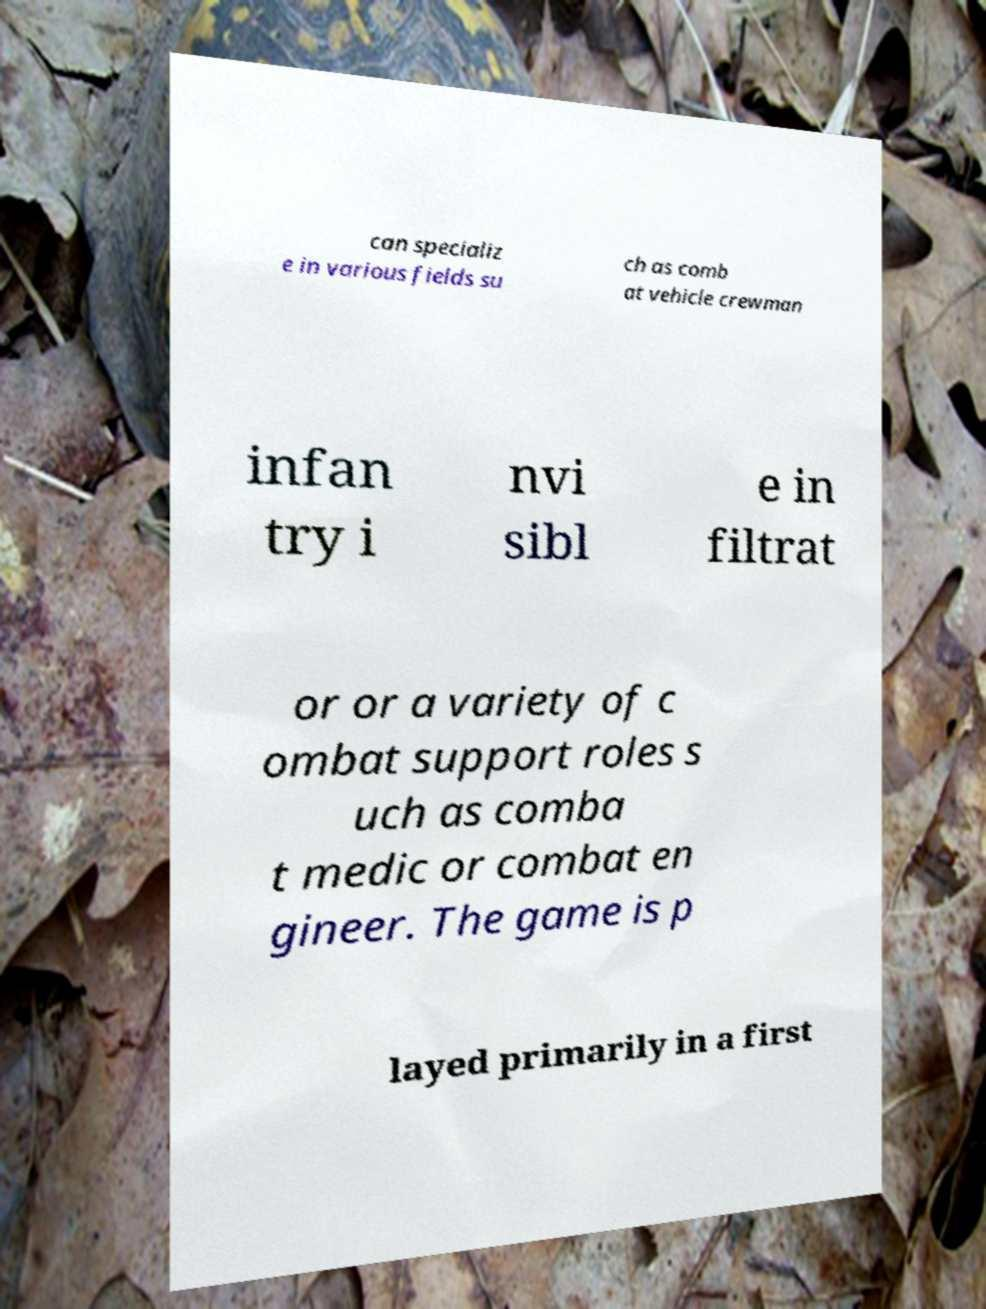Could you assist in decoding the text presented in this image and type it out clearly? can specializ e in various fields su ch as comb at vehicle crewman infan try i nvi sibl e in filtrat or or a variety of c ombat support roles s uch as comba t medic or combat en gineer. The game is p layed primarily in a first 